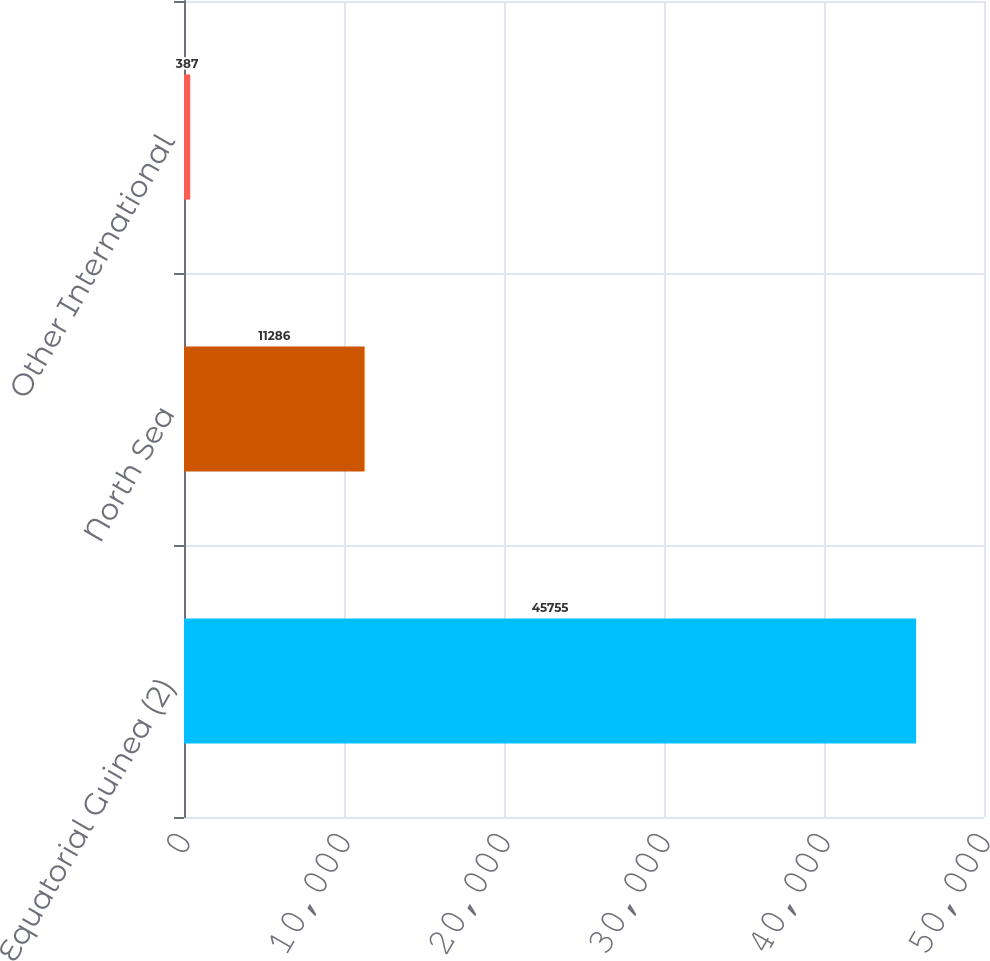Convert chart to OTSL. <chart><loc_0><loc_0><loc_500><loc_500><bar_chart><fcel>Equatorial Guinea (2)<fcel>North Sea<fcel>Other International<nl><fcel>45755<fcel>11286<fcel>387<nl></chart> 